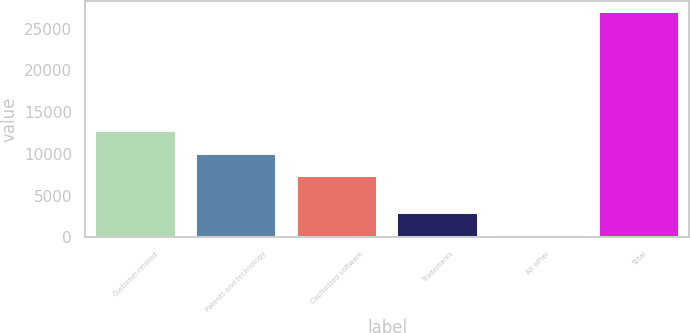<chart> <loc_0><loc_0><loc_500><loc_500><bar_chart><fcel>Customer-related<fcel>Patents and technology<fcel>Capitalized software<fcel>Trademarks<fcel>All other<fcel>Total<nl><fcel>12719.6<fcel>10047.3<fcel>7375<fcel>2939.3<fcel>267<fcel>26990<nl></chart> 